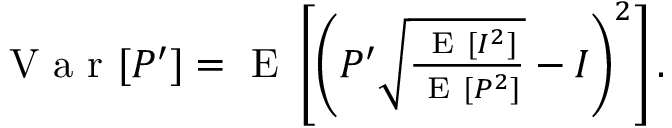<formula> <loc_0><loc_0><loc_500><loc_500>\begin{array} { r } { V a r [ P ^ { \prime } ] = E \left [ \left ( P ^ { \prime } \sqrt { \frac { E [ I ^ { 2 } ] } { E [ P ^ { 2 } ] } } - I \right ) ^ { 2 } \right ] . } \end{array}</formula> 